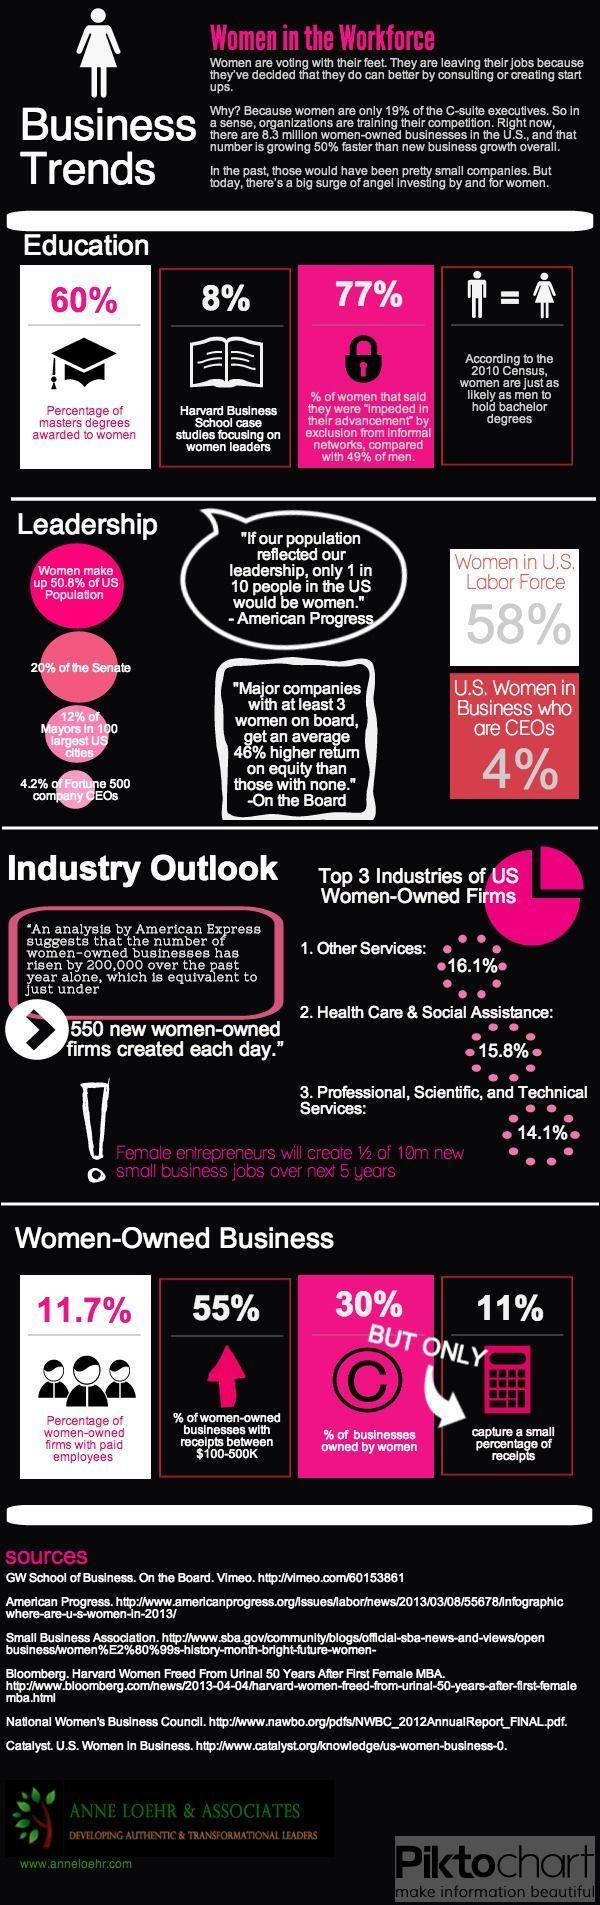What percent of masters degrees are awarded to men?
Answer the question with a short phrase. 40% How many sources are listed at the bottom? 6 